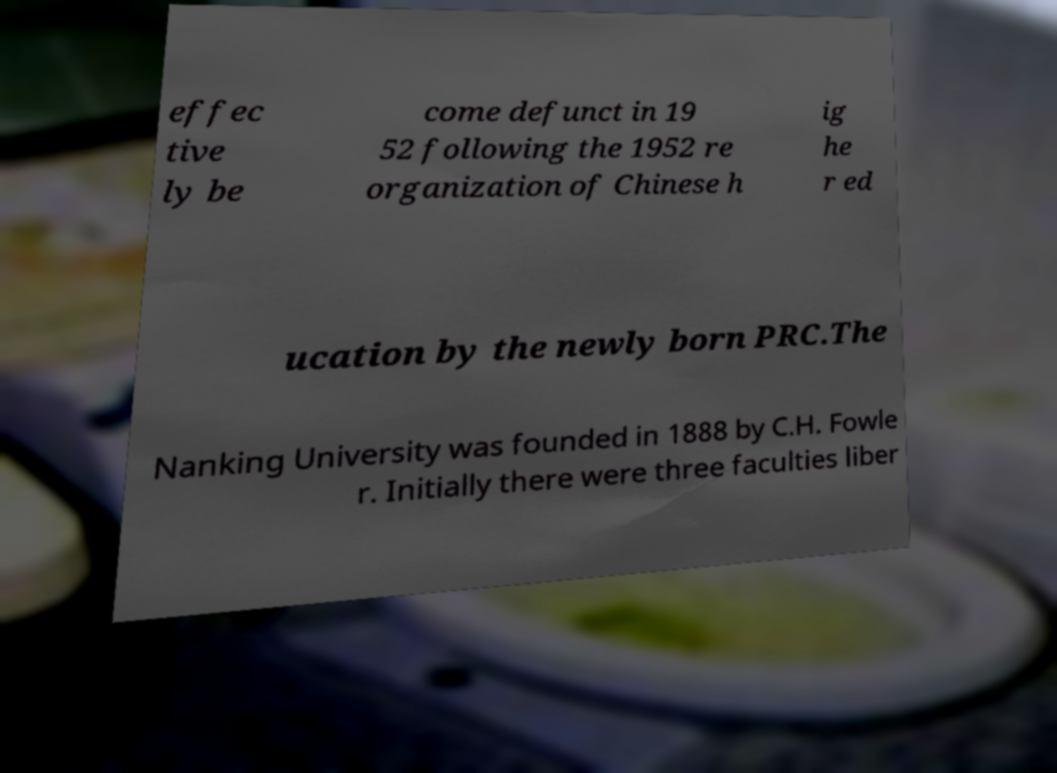There's text embedded in this image that I need extracted. Can you transcribe it verbatim? effec tive ly be come defunct in 19 52 following the 1952 re organization of Chinese h ig he r ed ucation by the newly born PRC.The Nanking University was founded in 1888 by C.H. Fowle r. Initially there were three faculties liber 